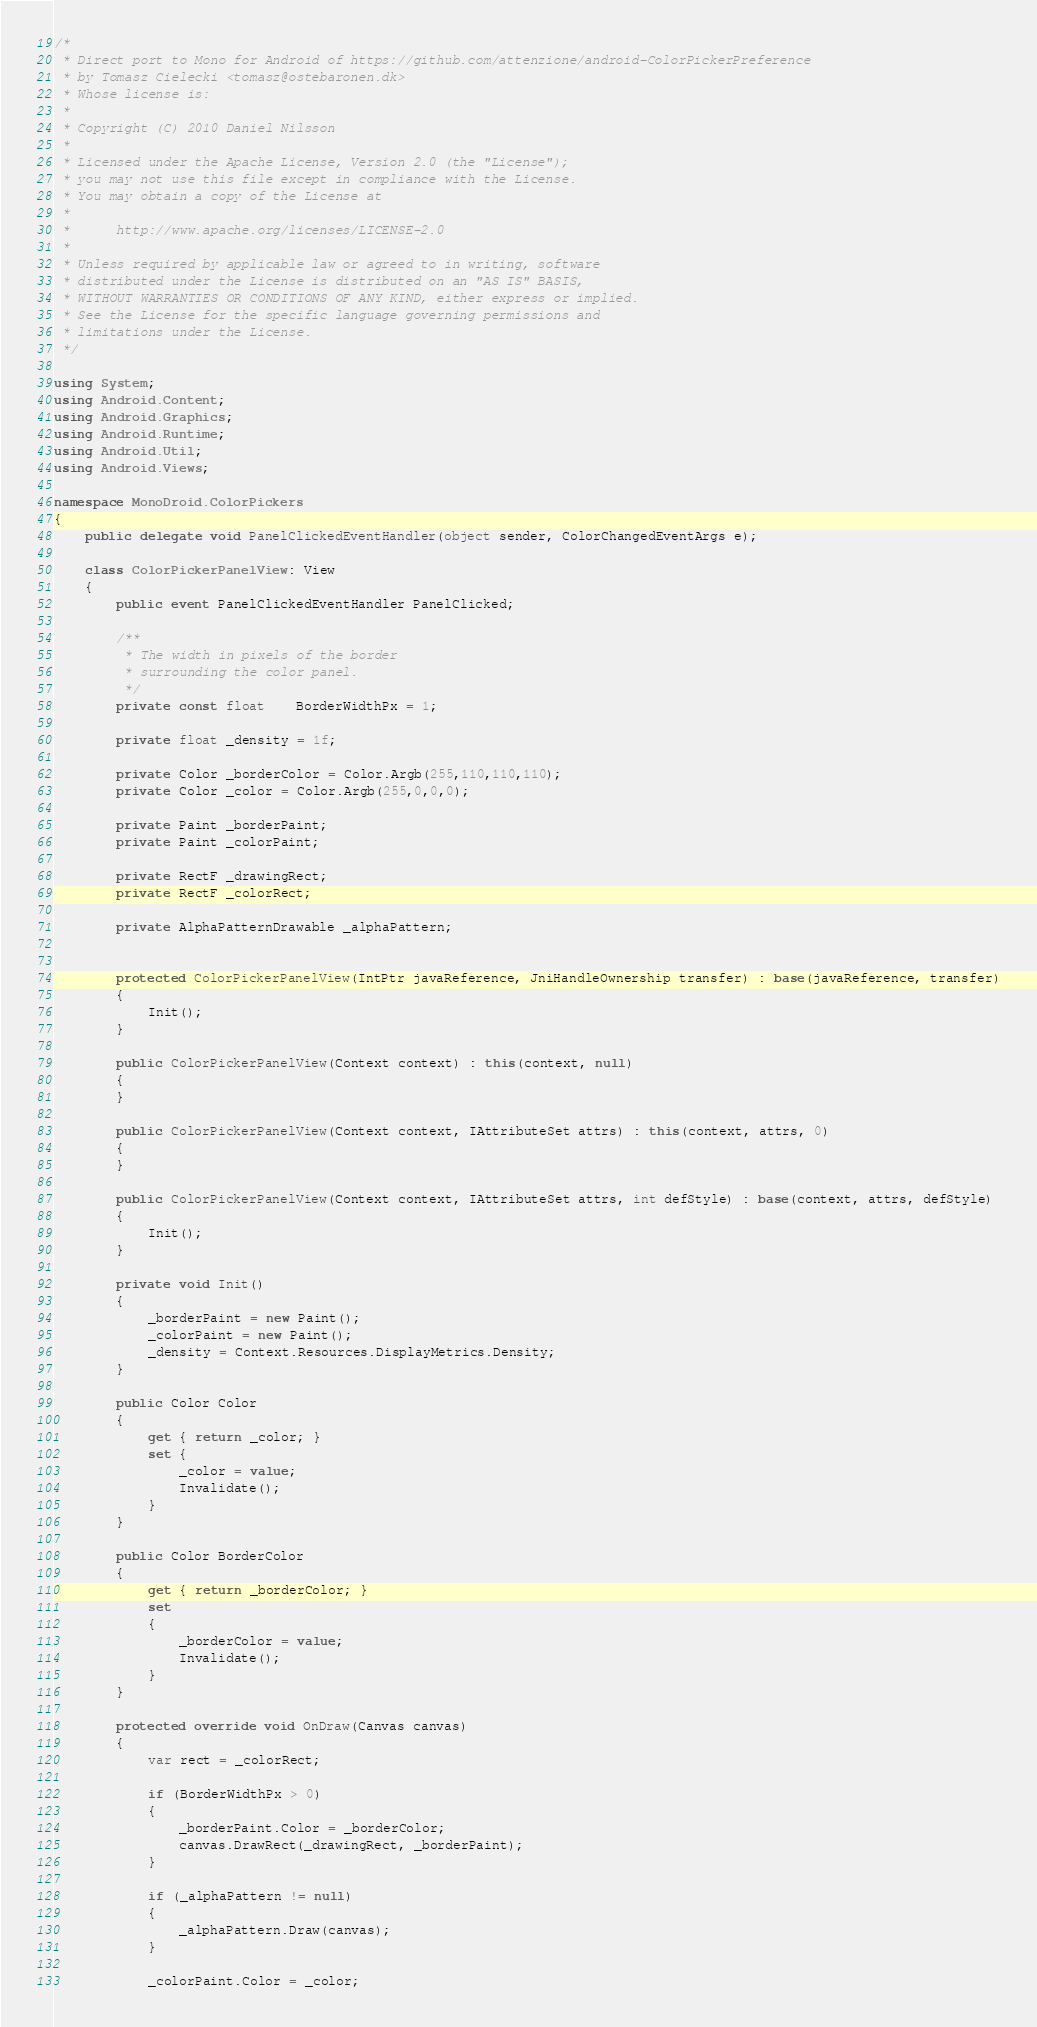Convert code to text. <code><loc_0><loc_0><loc_500><loc_500><_C#_>/*
 * Direct port to Mono for Android of https://github.com/attenzione/android-ColorPickerPreference
 * by Tomasz Cielecki <tomasz@ostebaronen.dk>
 * Whose license is:
 * 
 * Copyright (C) 2010 Daniel Nilsson
 *
 * Licensed under the Apache License, Version 2.0 (the "License");
 * you may not use this file except in compliance with the License.
 * You may obtain a copy of the License at
 *
 *      http://www.apache.org/licenses/LICENSE-2.0
 *
 * Unless required by applicable law or agreed to in writing, software
 * distributed under the License is distributed on an "AS IS" BASIS,
 * WITHOUT WARRANTIES OR CONDITIONS OF ANY KIND, either express or implied.
 * See the License for the specific language governing permissions and
 * limitations under the License.
 */

using System;
using Android.Content;
using Android.Graphics;
using Android.Runtime;
using Android.Util;
using Android.Views;

namespace MonoDroid.ColorPickers
{
    public delegate void PanelClickedEventHandler(object sender, ColorChangedEventArgs e);

    class ColorPickerPanelView: View
    {
        public event PanelClickedEventHandler PanelClicked;

        /**
	     * The width in pixels of the border
	     * surrounding the color panel.
	     */
	    private const float	BorderWidthPx = 1;

	    private float _density = 1f;

	    private Color _borderColor = Color.Argb(255,110,110,110);
	    private Color _color = Color.Argb(255,0,0,0);

	    private Paint _borderPaint;
	    private Paint _colorPaint;

	    private RectF _drawingRect;
	    private RectF _colorRect;

	    private AlphaPatternDrawable _alphaPattern;


        protected ColorPickerPanelView(IntPtr javaReference, JniHandleOwnership transfer) : base(javaReference, transfer)
        {
            Init();
        }

        public ColorPickerPanelView(Context context) : this(context, null)
        {
        }

        public ColorPickerPanelView(Context context, IAttributeSet attrs) : this(context, attrs, 0)
        {
        }

        public ColorPickerPanelView(Context context, IAttributeSet attrs, int defStyle) : base(context, attrs, defStyle)
        {
            Init();
        }

        private void Init()
        {
            _borderPaint = new Paint();
            _colorPaint = new Paint();
            _density = Context.Resources.DisplayMetrics.Density;
        }

        public Color Color
        {
            get { return _color; }
            set { 
                _color = value;
                Invalidate();
            }
        }

        public Color BorderColor
        {
            get { return _borderColor; }
            set
            {
                _borderColor = value;
                Invalidate();
            }
        }

        protected override void OnDraw(Canvas canvas)
        {
            var rect = _colorRect;

            if (BorderWidthPx > 0)
            {
                _borderPaint.Color = _borderColor;
                canvas.DrawRect(_drawingRect, _borderPaint);
		    }

            if (_alphaPattern != null)
            {
                _alphaPattern.Draw(canvas);
		    }

            _colorPaint.Color = _color;
</code> 